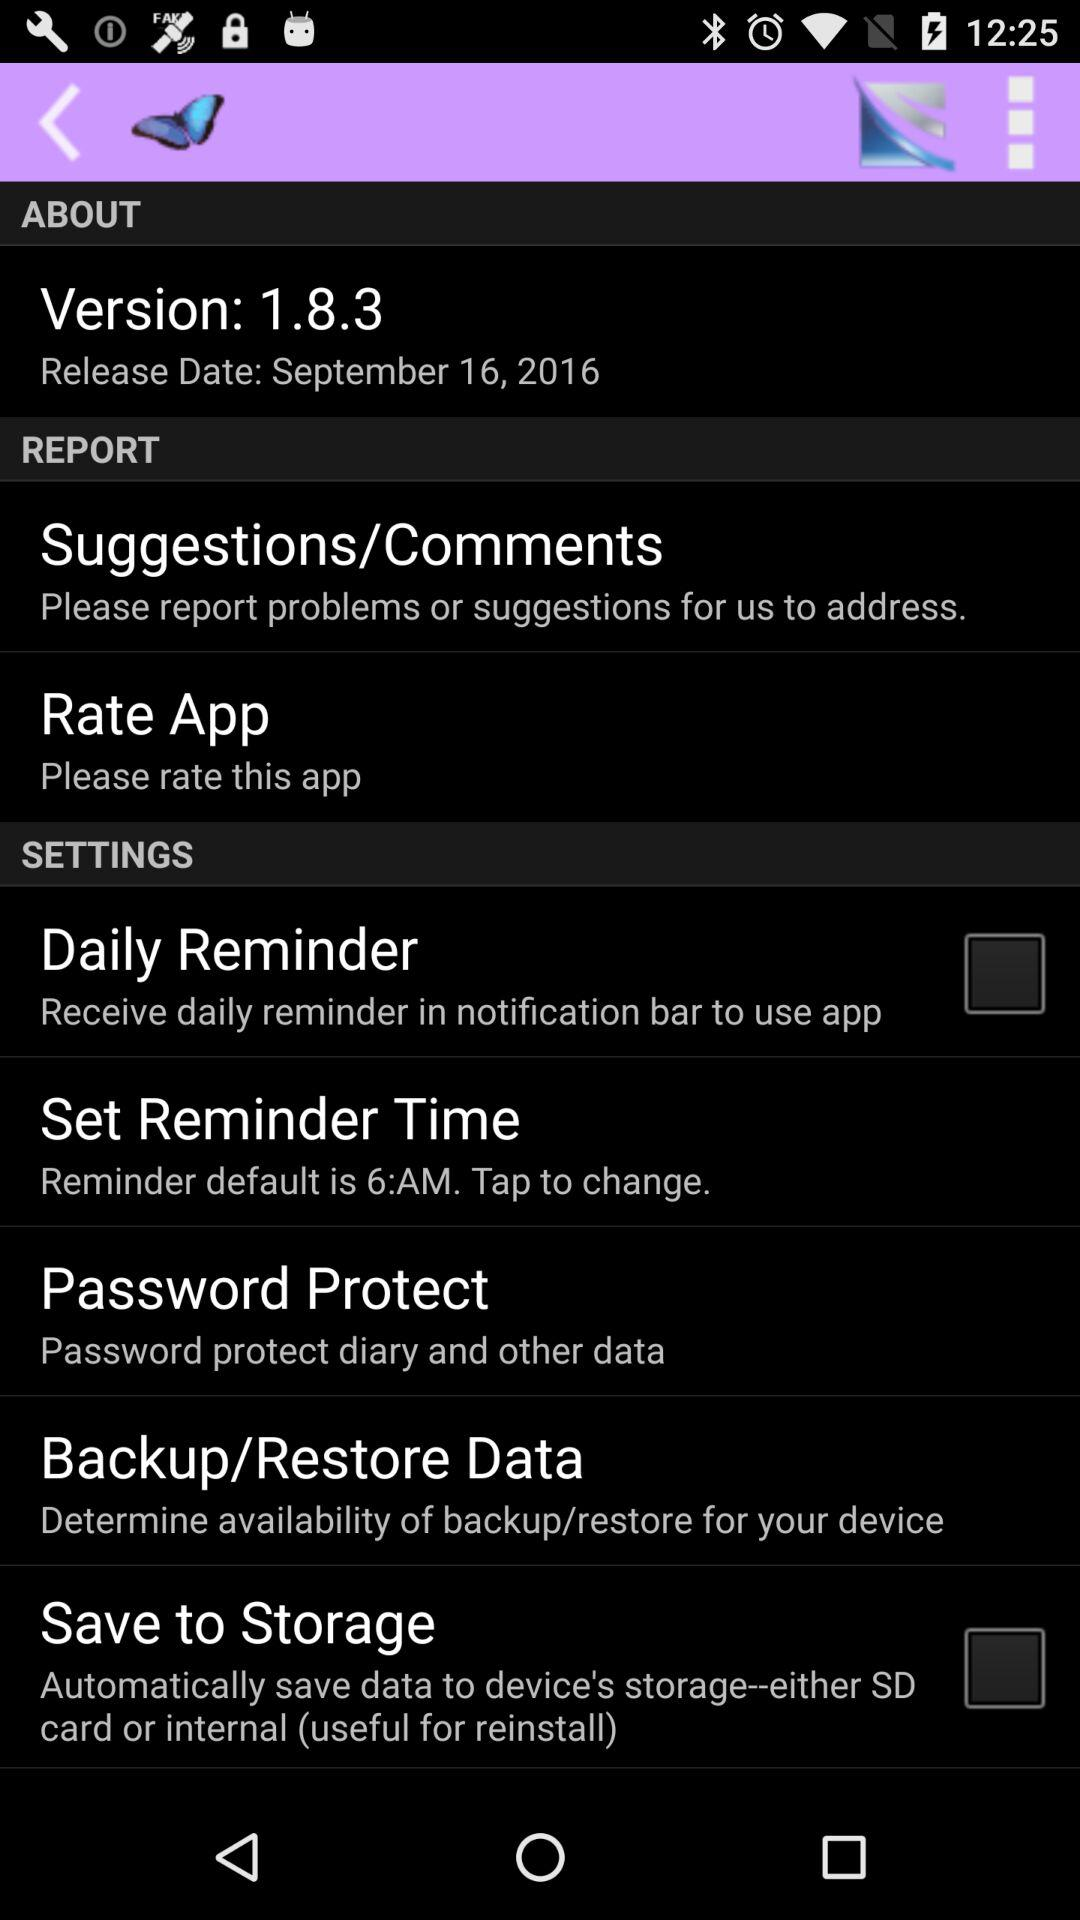How many items have a checkbox next to them?
Answer the question using a single word or phrase. 2 